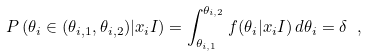Convert formula to latex. <formula><loc_0><loc_0><loc_500><loc_500>P \left ( \theta _ { i } \in ( \theta _ { i , 1 } , \theta _ { i , 2 } ) | x _ { i } I \right ) = \int _ { \theta _ { i , 1 } } ^ { \theta _ { i , 2 } } f ( \theta _ { i } | x _ { i } I ) \, d \theta _ { i } = \delta \ ,</formula> 